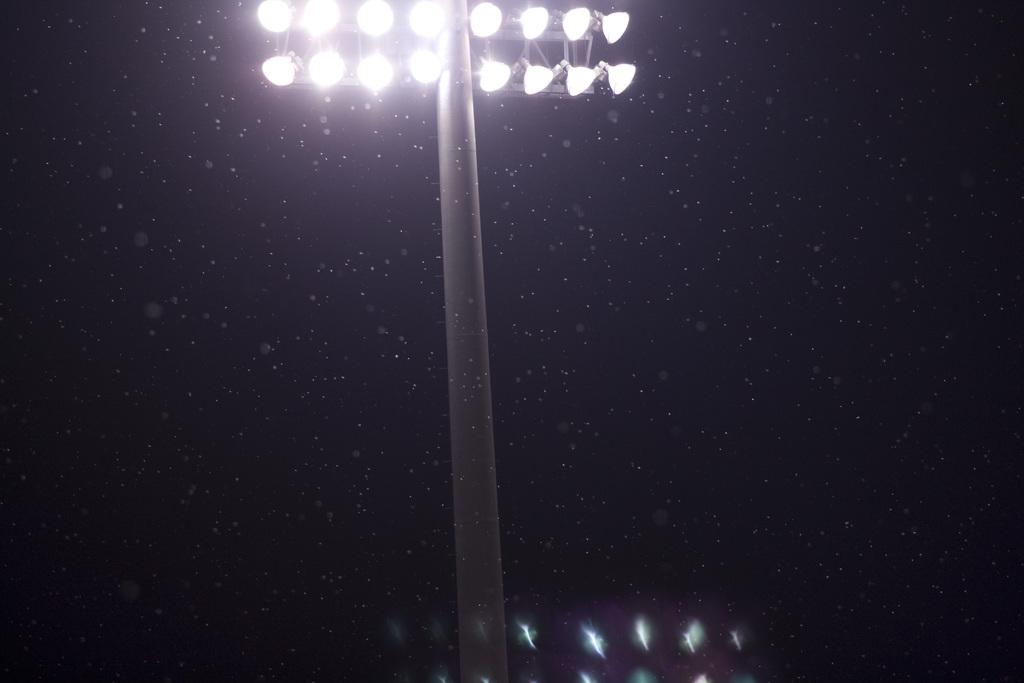What type of lighting equipment is present on a pole in the image? There are flood lights on a pole in the image. What can be observed about the background of the image? The background of the image is dark. What type of cloth is draped over the flood lights in the image? There is no cloth draped over the flood lights in the image. How many clover leaves can be seen growing near the flood lights in the image? There are no clover leaves present in the image. 